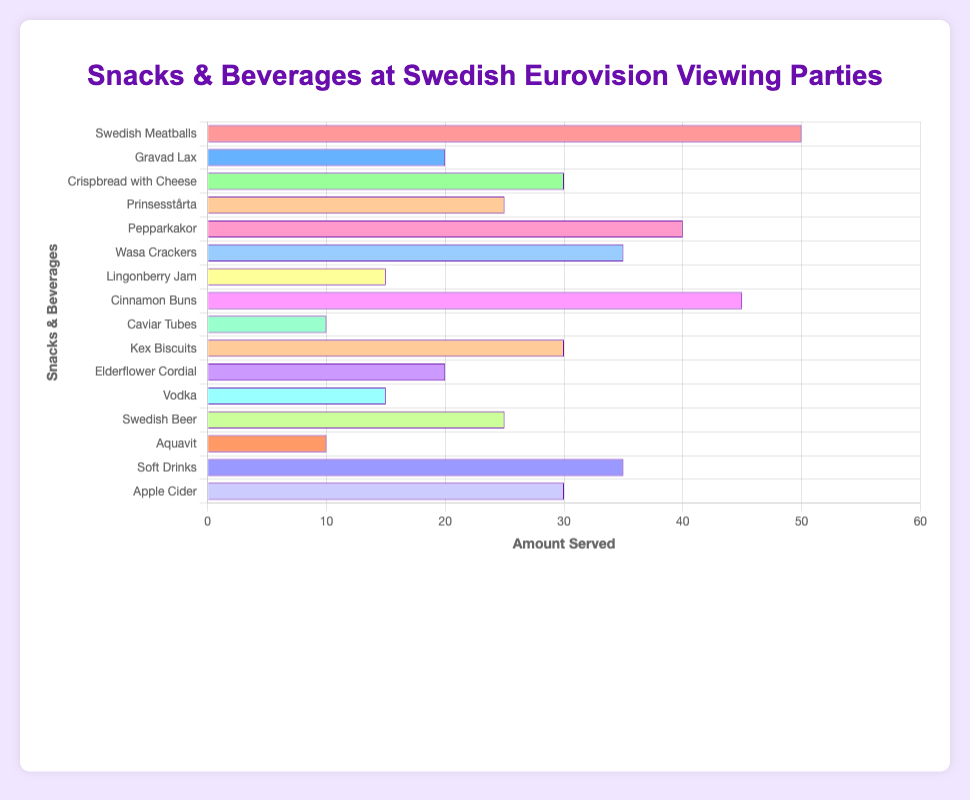What is the most served item? The first bar from the top is the longest, showing the highest 'amount served’. This bar represents 'Swedish Meatballs', indicating it is the most served item.
Answer: Swedish Meatballs Which item has the least amount served? The smallest bar represents 'Caviar Tubes' and 'Aquavit' which both have the shortest length, indicating they are served the least.
Answer: Caviar Tubes, Aquavit How many items have exactly 30 amounts served? Scan the chart to find bars with a length corresponding to 30 units. The bars for 'Crispbread with Cheese', 'Kex Biscuits', and 'Apple Cider' match this amount.
Answer: 3 What is the total amount served for 'Prinsesstårta' and 'Swedish Beer'? Locate the bars for 'Prinsesstårta' and 'Swedish Beer', and sum their values: 25 + 25.
Answer: 50 What is the difference in amount served between 'Cinnamon Buns' and 'Gravad Lax'? Locate 'Cinnamon Buns' (45) and 'Gravad Lax' (20) bars and find the difference: 45 - 20.
Answer: 25 Which beverage is served more, 'Vodka' or 'Elderflower Cordial'? Compare the length of the bars for 'Vodka' and 'Elderflower Cordial'. 'Elderflower Cordial' has a longer bar indicating a greater amount served.
Answer: Elderflower Cordial How many items have more than 35 amounts served? Count the bars that exceed the 35-unit mark. The bars for 'Swedish Meatballs', 'Pepparkakor', 'Cinnamon Buns', and 'Soft Drinks' match this criterion.
Answer: 4 What are the combined amounts of 'Wasa Crackers' and 'Soft Drinks'? Add the values of 'Wasa Crackers' (35) and 'Soft Drinks' (35): 35 + 35.
Answer: 70 Does 'Lingonberry Jam' have more or less amount served than 'Vodka'? Compare the length of the bars for 'Lingonberry Jam' (15) and 'Vodka' (15). They are equal in length and thus have the same amount served.
Answer: Equal What is the average amount served among 'Kex Biscuits', 'Apple Cider', and 'Crispbread with Cheese'? Add the values of these items and divide by 3: (30 + 30 + 30)/3.
Answer: 30 